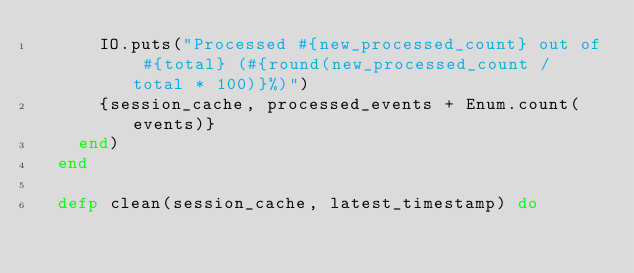Convert code to text. <code><loc_0><loc_0><loc_500><loc_500><_Elixir_>      IO.puts("Processed #{new_processed_count} out of #{total} (#{round(new_processed_count / total * 100)}%)")
      {session_cache, processed_events + Enum.count(events)}
    end)
  end

  defp clean(session_cache, latest_timestamp) do</code> 